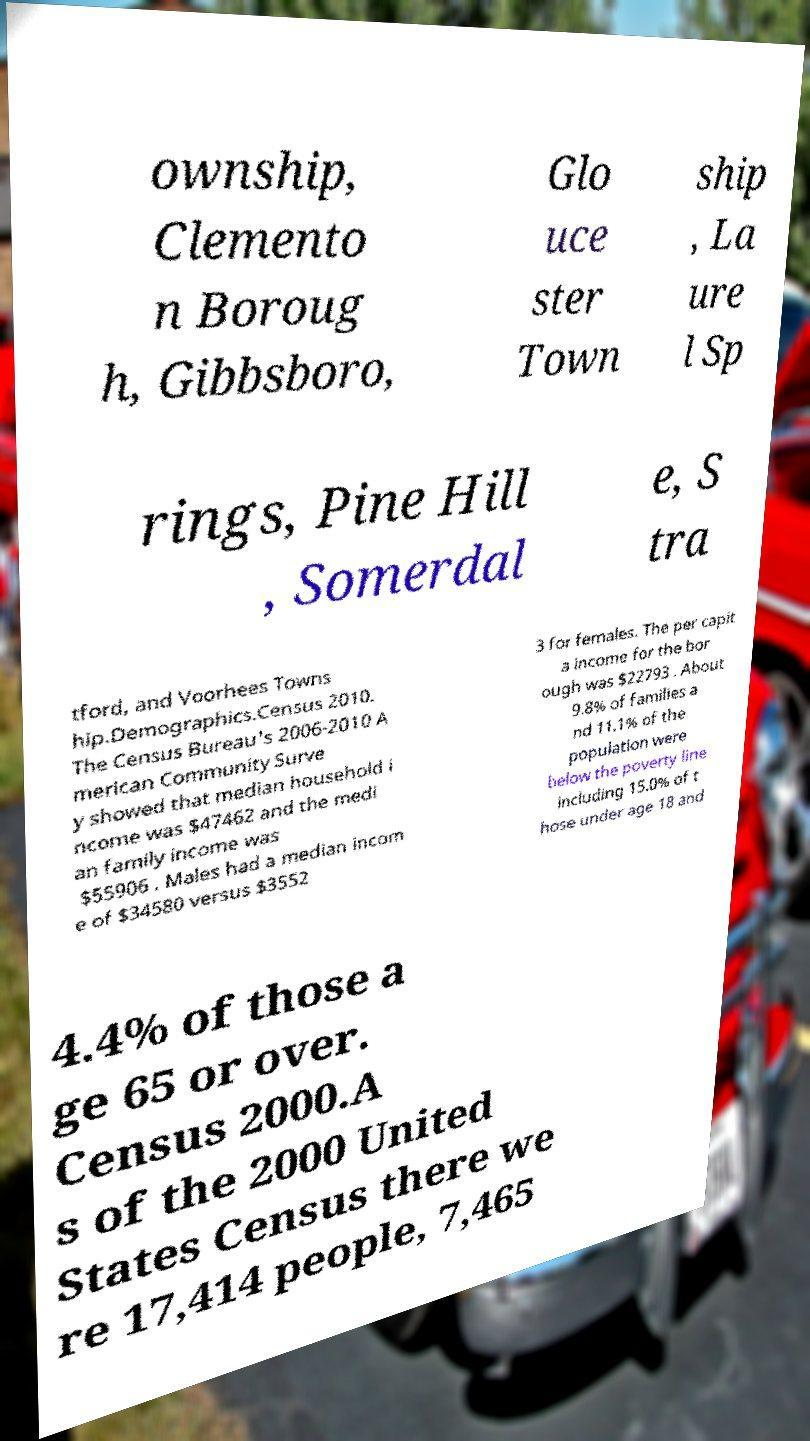There's text embedded in this image that I need extracted. Can you transcribe it verbatim? ownship, Clemento n Boroug h, Gibbsboro, Glo uce ster Town ship , La ure l Sp rings, Pine Hill , Somerdal e, S tra tford, and Voorhees Towns hip.Demographics.Census 2010. The Census Bureau's 2006-2010 A merican Community Surve y showed that median household i ncome was $47462 and the medi an family income was $55906 . Males had a median incom e of $34580 versus $3552 3 for females. The per capit a income for the bor ough was $22793 . About 9.8% of families a nd 11.1% of the population were below the poverty line including 15.0% of t hose under age 18 and 4.4% of those a ge 65 or over. Census 2000.A s of the 2000 United States Census there we re 17,414 people, 7,465 